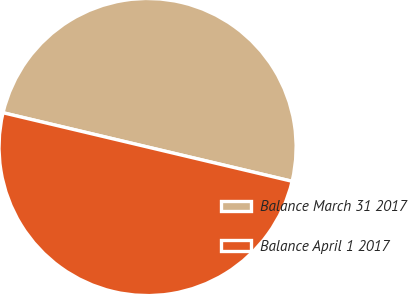Convert chart. <chart><loc_0><loc_0><loc_500><loc_500><pie_chart><fcel>Balance March 31 2017<fcel>Balance April 1 2017<nl><fcel>50.0%<fcel>50.0%<nl></chart> 